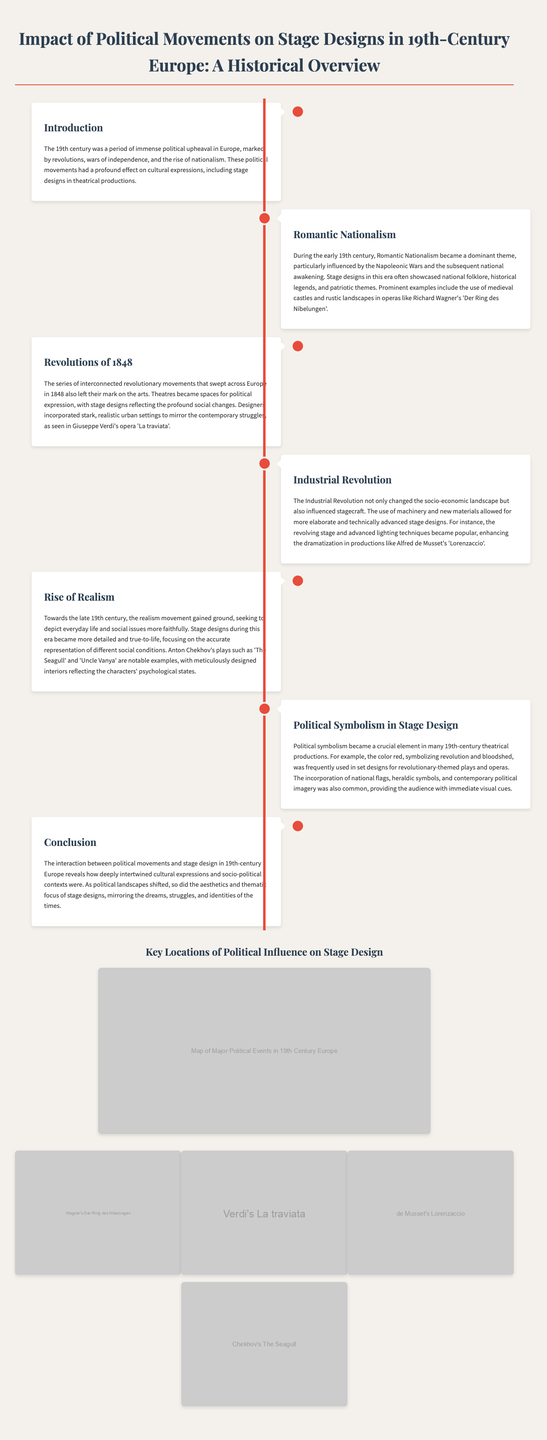what major theme influenced stage designs in the early 19th century? The major theme was Romantic Nationalism, influenced by the Napoleonic Wars.
Answer: Romantic Nationalism which opera is associated with the use of medieval castles in stage design? Richard Wagner's 'Der Ring des Nibelungen' features medieval castles in its stage design.
Answer: 'Der Ring des Nibelungen' what year did the series of revolutions that impacted stage design occur? The revolutions that influenced stage design happened in 1848.
Answer: 1848 what advancement in stagecraft was popularized during the Industrial Revolution? The revolving stage and advanced lighting techniques became popular during this period.
Answer: revolving stage how did stage designs in the late 19th century reflect social conditions? Stage designs became more detailed and true-to-life, focusing on accurate representation.
Answer: detailed and true-to-life which color symbolized revolution in 19th-century stage designs? The color red symbolized revolution and bloodshed in stage designs.
Answer: red what is one key function of stage designs during the revolutions of 1848? Theatres became spaces for political expression during the revolutions.
Answer: political expression what is depicted in the infographic alongside political movements? The infographic depicts the impact of political movements on stage design.
Answer: stage design 